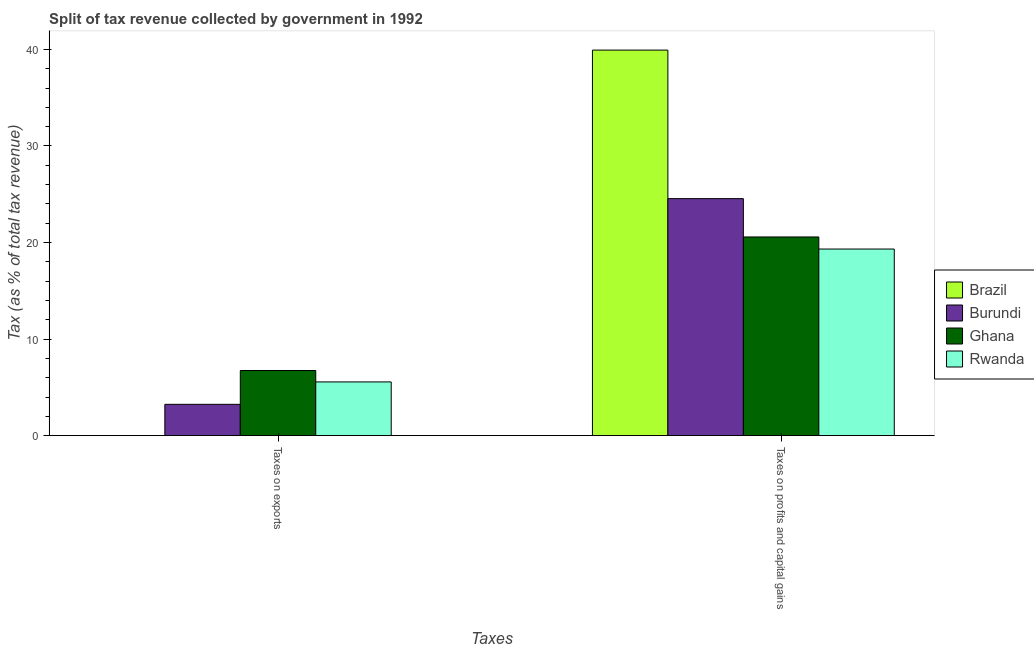How many different coloured bars are there?
Offer a terse response. 4. Are the number of bars per tick equal to the number of legend labels?
Your answer should be very brief. Yes. How many bars are there on the 1st tick from the left?
Offer a very short reply. 4. How many bars are there on the 1st tick from the right?
Offer a very short reply. 4. What is the label of the 1st group of bars from the left?
Provide a short and direct response. Taxes on exports. What is the percentage of revenue obtained from taxes on profits and capital gains in Burundi?
Your answer should be very brief. 24.54. Across all countries, what is the maximum percentage of revenue obtained from taxes on exports?
Offer a terse response. 6.75. Across all countries, what is the minimum percentage of revenue obtained from taxes on profits and capital gains?
Your answer should be very brief. 19.32. In which country was the percentage of revenue obtained from taxes on profits and capital gains maximum?
Give a very brief answer. Brazil. In which country was the percentage of revenue obtained from taxes on exports minimum?
Provide a succinct answer. Brazil. What is the total percentage of revenue obtained from taxes on exports in the graph?
Give a very brief answer. 15.55. What is the difference between the percentage of revenue obtained from taxes on profits and capital gains in Brazil and that in Burundi?
Keep it short and to the point. 15.38. What is the difference between the percentage of revenue obtained from taxes on profits and capital gains in Brazil and the percentage of revenue obtained from taxes on exports in Rwanda?
Ensure brevity in your answer.  34.36. What is the average percentage of revenue obtained from taxes on exports per country?
Your answer should be compact. 3.89. What is the difference between the percentage of revenue obtained from taxes on exports and percentage of revenue obtained from taxes on profits and capital gains in Burundi?
Make the answer very short. -21.3. In how many countries, is the percentage of revenue obtained from taxes on exports greater than 18 %?
Provide a short and direct response. 0. What is the ratio of the percentage of revenue obtained from taxes on exports in Brazil to that in Burundi?
Your answer should be compact. 0. In how many countries, is the percentage of revenue obtained from taxes on exports greater than the average percentage of revenue obtained from taxes on exports taken over all countries?
Offer a very short reply. 2. What does the 3rd bar from the left in Taxes on exports represents?
Make the answer very short. Ghana. What does the 1st bar from the right in Taxes on exports represents?
Give a very brief answer. Rwanda. How many bars are there?
Offer a terse response. 8. Are the values on the major ticks of Y-axis written in scientific E-notation?
Keep it short and to the point. No. Does the graph contain any zero values?
Provide a succinct answer. No. Where does the legend appear in the graph?
Provide a succinct answer. Center right. What is the title of the graph?
Keep it short and to the point. Split of tax revenue collected by government in 1992. What is the label or title of the X-axis?
Ensure brevity in your answer.  Taxes. What is the label or title of the Y-axis?
Your answer should be compact. Tax (as % of total tax revenue). What is the Tax (as % of total tax revenue) of Brazil in Taxes on exports?
Provide a short and direct response. 0. What is the Tax (as % of total tax revenue) of Burundi in Taxes on exports?
Provide a succinct answer. 3.24. What is the Tax (as % of total tax revenue) in Ghana in Taxes on exports?
Ensure brevity in your answer.  6.75. What is the Tax (as % of total tax revenue) in Rwanda in Taxes on exports?
Offer a very short reply. 5.56. What is the Tax (as % of total tax revenue) of Brazil in Taxes on profits and capital gains?
Offer a very short reply. 39.93. What is the Tax (as % of total tax revenue) in Burundi in Taxes on profits and capital gains?
Give a very brief answer. 24.54. What is the Tax (as % of total tax revenue) in Ghana in Taxes on profits and capital gains?
Make the answer very short. 20.57. What is the Tax (as % of total tax revenue) of Rwanda in Taxes on profits and capital gains?
Keep it short and to the point. 19.32. Across all Taxes, what is the maximum Tax (as % of total tax revenue) in Brazil?
Ensure brevity in your answer.  39.93. Across all Taxes, what is the maximum Tax (as % of total tax revenue) in Burundi?
Keep it short and to the point. 24.54. Across all Taxes, what is the maximum Tax (as % of total tax revenue) in Ghana?
Your answer should be compact. 20.57. Across all Taxes, what is the maximum Tax (as % of total tax revenue) of Rwanda?
Your response must be concise. 19.32. Across all Taxes, what is the minimum Tax (as % of total tax revenue) in Brazil?
Your answer should be compact. 0. Across all Taxes, what is the minimum Tax (as % of total tax revenue) of Burundi?
Provide a short and direct response. 3.24. Across all Taxes, what is the minimum Tax (as % of total tax revenue) of Ghana?
Offer a very short reply. 6.75. Across all Taxes, what is the minimum Tax (as % of total tax revenue) in Rwanda?
Provide a succinct answer. 5.56. What is the total Tax (as % of total tax revenue) of Brazil in the graph?
Your response must be concise. 39.93. What is the total Tax (as % of total tax revenue) of Burundi in the graph?
Your answer should be very brief. 27.79. What is the total Tax (as % of total tax revenue) in Ghana in the graph?
Ensure brevity in your answer.  27.32. What is the total Tax (as % of total tax revenue) of Rwanda in the graph?
Ensure brevity in your answer.  24.89. What is the difference between the Tax (as % of total tax revenue) in Brazil in Taxes on exports and that in Taxes on profits and capital gains?
Offer a very short reply. -39.92. What is the difference between the Tax (as % of total tax revenue) in Burundi in Taxes on exports and that in Taxes on profits and capital gains?
Your answer should be very brief. -21.3. What is the difference between the Tax (as % of total tax revenue) in Ghana in Taxes on exports and that in Taxes on profits and capital gains?
Keep it short and to the point. -13.83. What is the difference between the Tax (as % of total tax revenue) in Rwanda in Taxes on exports and that in Taxes on profits and capital gains?
Provide a short and direct response. -13.76. What is the difference between the Tax (as % of total tax revenue) of Brazil in Taxes on exports and the Tax (as % of total tax revenue) of Burundi in Taxes on profits and capital gains?
Ensure brevity in your answer.  -24.54. What is the difference between the Tax (as % of total tax revenue) in Brazil in Taxes on exports and the Tax (as % of total tax revenue) in Ghana in Taxes on profits and capital gains?
Provide a short and direct response. -20.57. What is the difference between the Tax (as % of total tax revenue) of Brazil in Taxes on exports and the Tax (as % of total tax revenue) of Rwanda in Taxes on profits and capital gains?
Ensure brevity in your answer.  -19.32. What is the difference between the Tax (as % of total tax revenue) of Burundi in Taxes on exports and the Tax (as % of total tax revenue) of Ghana in Taxes on profits and capital gains?
Provide a succinct answer. -17.33. What is the difference between the Tax (as % of total tax revenue) of Burundi in Taxes on exports and the Tax (as % of total tax revenue) of Rwanda in Taxes on profits and capital gains?
Your answer should be compact. -16.08. What is the difference between the Tax (as % of total tax revenue) of Ghana in Taxes on exports and the Tax (as % of total tax revenue) of Rwanda in Taxes on profits and capital gains?
Provide a short and direct response. -12.58. What is the average Tax (as % of total tax revenue) of Brazil per Taxes?
Provide a succinct answer. 19.96. What is the average Tax (as % of total tax revenue) in Burundi per Taxes?
Offer a terse response. 13.89. What is the average Tax (as % of total tax revenue) of Ghana per Taxes?
Keep it short and to the point. 13.66. What is the average Tax (as % of total tax revenue) in Rwanda per Taxes?
Ensure brevity in your answer.  12.44. What is the difference between the Tax (as % of total tax revenue) of Brazil and Tax (as % of total tax revenue) of Burundi in Taxes on exports?
Keep it short and to the point. -3.24. What is the difference between the Tax (as % of total tax revenue) in Brazil and Tax (as % of total tax revenue) in Ghana in Taxes on exports?
Give a very brief answer. -6.74. What is the difference between the Tax (as % of total tax revenue) of Brazil and Tax (as % of total tax revenue) of Rwanda in Taxes on exports?
Your answer should be very brief. -5.56. What is the difference between the Tax (as % of total tax revenue) of Burundi and Tax (as % of total tax revenue) of Ghana in Taxes on exports?
Your response must be concise. -3.5. What is the difference between the Tax (as % of total tax revenue) of Burundi and Tax (as % of total tax revenue) of Rwanda in Taxes on exports?
Your answer should be compact. -2.32. What is the difference between the Tax (as % of total tax revenue) in Ghana and Tax (as % of total tax revenue) in Rwanda in Taxes on exports?
Provide a succinct answer. 1.18. What is the difference between the Tax (as % of total tax revenue) of Brazil and Tax (as % of total tax revenue) of Burundi in Taxes on profits and capital gains?
Give a very brief answer. 15.38. What is the difference between the Tax (as % of total tax revenue) of Brazil and Tax (as % of total tax revenue) of Ghana in Taxes on profits and capital gains?
Ensure brevity in your answer.  19.35. What is the difference between the Tax (as % of total tax revenue) in Brazil and Tax (as % of total tax revenue) in Rwanda in Taxes on profits and capital gains?
Give a very brief answer. 20.6. What is the difference between the Tax (as % of total tax revenue) in Burundi and Tax (as % of total tax revenue) in Ghana in Taxes on profits and capital gains?
Provide a succinct answer. 3.97. What is the difference between the Tax (as % of total tax revenue) in Burundi and Tax (as % of total tax revenue) in Rwanda in Taxes on profits and capital gains?
Make the answer very short. 5.22. What is the difference between the Tax (as % of total tax revenue) in Ghana and Tax (as % of total tax revenue) in Rwanda in Taxes on profits and capital gains?
Offer a terse response. 1.25. What is the ratio of the Tax (as % of total tax revenue) in Brazil in Taxes on exports to that in Taxes on profits and capital gains?
Provide a short and direct response. 0. What is the ratio of the Tax (as % of total tax revenue) of Burundi in Taxes on exports to that in Taxes on profits and capital gains?
Give a very brief answer. 0.13. What is the ratio of the Tax (as % of total tax revenue) in Ghana in Taxes on exports to that in Taxes on profits and capital gains?
Your answer should be compact. 0.33. What is the ratio of the Tax (as % of total tax revenue) in Rwanda in Taxes on exports to that in Taxes on profits and capital gains?
Give a very brief answer. 0.29. What is the difference between the highest and the second highest Tax (as % of total tax revenue) in Brazil?
Make the answer very short. 39.92. What is the difference between the highest and the second highest Tax (as % of total tax revenue) of Burundi?
Give a very brief answer. 21.3. What is the difference between the highest and the second highest Tax (as % of total tax revenue) in Ghana?
Ensure brevity in your answer.  13.83. What is the difference between the highest and the second highest Tax (as % of total tax revenue) in Rwanda?
Make the answer very short. 13.76. What is the difference between the highest and the lowest Tax (as % of total tax revenue) in Brazil?
Keep it short and to the point. 39.92. What is the difference between the highest and the lowest Tax (as % of total tax revenue) of Burundi?
Provide a succinct answer. 21.3. What is the difference between the highest and the lowest Tax (as % of total tax revenue) of Ghana?
Keep it short and to the point. 13.83. What is the difference between the highest and the lowest Tax (as % of total tax revenue) in Rwanda?
Provide a short and direct response. 13.76. 